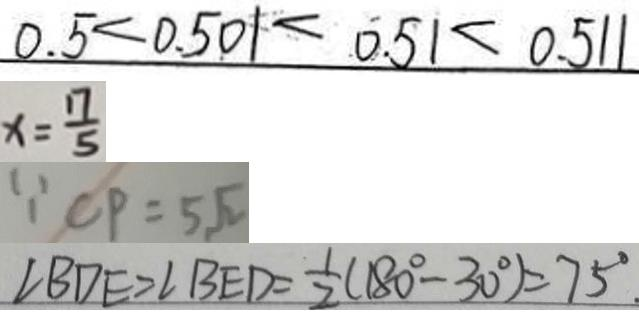Convert formula to latex. <formula><loc_0><loc_0><loc_500><loc_500>0 . 5 < 0 . 5 0 1 < 0 . 5 1 < 0 . 5 1 1 
 x = \frac { 1 7 } { 5 } 
 \because C P = 5 \sqrt { 2 } 
 \angle B D E = \angle B E D = \frac { 1 } { 2 } ( 1 8 0 ^ { \circ } - 3 0 ^ { \circ } ) = 7 5 ^ { \circ } .</formula> 